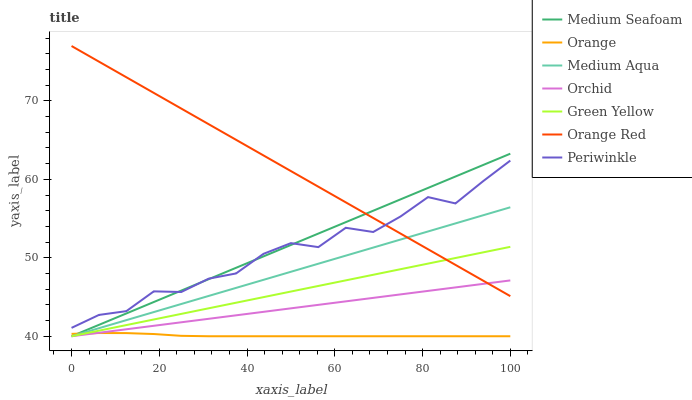Does Orange have the minimum area under the curve?
Answer yes or no. Yes. Does Orange Red have the maximum area under the curve?
Answer yes or no. Yes. Does Medium Aqua have the minimum area under the curve?
Answer yes or no. No. Does Medium Aqua have the maximum area under the curve?
Answer yes or no. No. Is Medium Aqua the smoothest?
Answer yes or no. Yes. Is Periwinkle the roughest?
Answer yes or no. Yes. Is Orange the smoothest?
Answer yes or no. No. Is Orange the roughest?
Answer yes or no. No. Does Medium Aqua have the lowest value?
Answer yes or no. Yes. Does Periwinkle have the lowest value?
Answer yes or no. No. Does Orange Red have the highest value?
Answer yes or no. Yes. Does Medium Aqua have the highest value?
Answer yes or no. No. Is Orchid less than Periwinkle?
Answer yes or no. Yes. Is Orange Red greater than Orange?
Answer yes or no. Yes. Does Orange intersect Green Yellow?
Answer yes or no. Yes. Is Orange less than Green Yellow?
Answer yes or no. No. Is Orange greater than Green Yellow?
Answer yes or no. No. Does Orchid intersect Periwinkle?
Answer yes or no. No. 